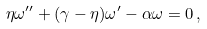<formula> <loc_0><loc_0><loc_500><loc_500>\eta \omega ^ { \prime \prime } + ( \gamma - \eta ) \omega ^ { \prime } - \alpha \omega = 0 \, ,</formula> 